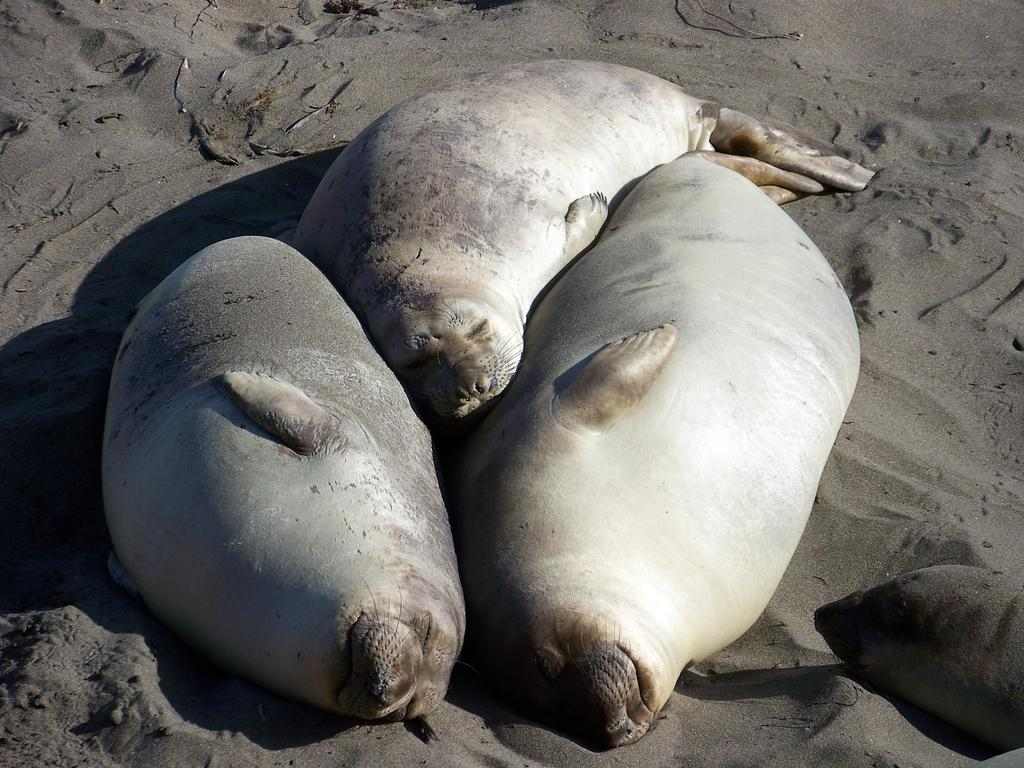What type of animals are in the picture? There are harbor seal animals in the picture. What are the harbor seal animals doing in the picture? The harbor seal animals are sleeping. Where are the harbor seal animals located in the picture? The harbor seal animals are on the sand. What type of rifle can be seen in the picture? There is no rifle present in the picture; it features harbor seal animals sleeping on the sand. 